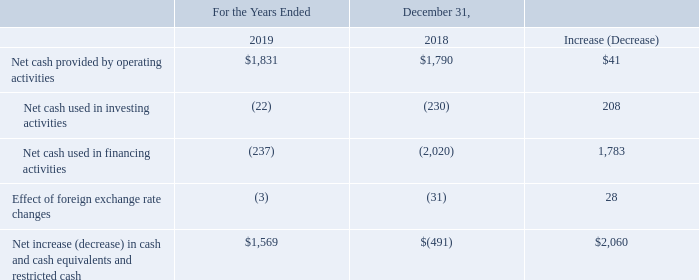Liquidity and Capital Resources
We believe our ability to generate cash flows from operating activities is one of our fundamental financial strengths. In the near term, we expect our business and financial condition to remain strong and to continue to generate significant operating cash flows, which, we believe, in combination with our existing balance of cash and cash equivalents and short-term investments of $5.9 billion, our access to capital, and the availability of our $1.5 billion revolving credit facility, will be sufficient to finance our operational and financing requirements for the next 12 months. Our primary sources of liquidity, which are available to us to fund cash outflows such as potential dividend payments or share repurchases, and scheduled debt maturities, include our cash and cash equivalents, short-term investments, and cash flows provided by operating activities.
As of December 31, 2019, the amount of cash and cash equivalents held outside of the U.S. by our foreign subsidiaries was $2.8 billion, as compared to $1.4 billion as of December 31, 2018. These cash balances are generally available for use in the U.S., subject in some cases to certain restrictions.
Our cash provided from operating activities is somewhat impacted by seasonality. Working capital needs are impacted by weekly sales, which are generally highest in the fourth quarter due to seasonal and holiday-related sales patterns. We consider, on a continuing basis, various transactions to increase shareholder value and enhance our business results, including acquisitions, divestitures, joint ventures, share repurchases, and other structural changes. These transactions may result in future cash proceeds or payments.
Sources of Liquidity (amounts in millions)
According to the company, what are working capital needs impacted by? Weekly sales. What was the Net cash provided by operating activities in 2019?
Answer scale should be: million. $1,831. What was the Net cash provided by operating activities in 2018?
Answer scale should be: million. $1,790. What was the percentage change in Net cash provided by operating activities between 2018 and 2019?
Answer scale should be: percent. ($1,831-$1,790)/$1,790
Answer: 2.29. What is the increase(decrease) in Net cash provided by operating activities as a percentage of Increase (Decrease) of Net cash used in investing activities?
Answer scale should be: percent. 41/208
Answer: 19.71. What is the increase(decrease) in Net cash provided by operating activities as a percentage of Increase (Decrease) in Net cash used in financing activities?
Answer scale should be: percent. 41/1,783
Answer: 2.3. 